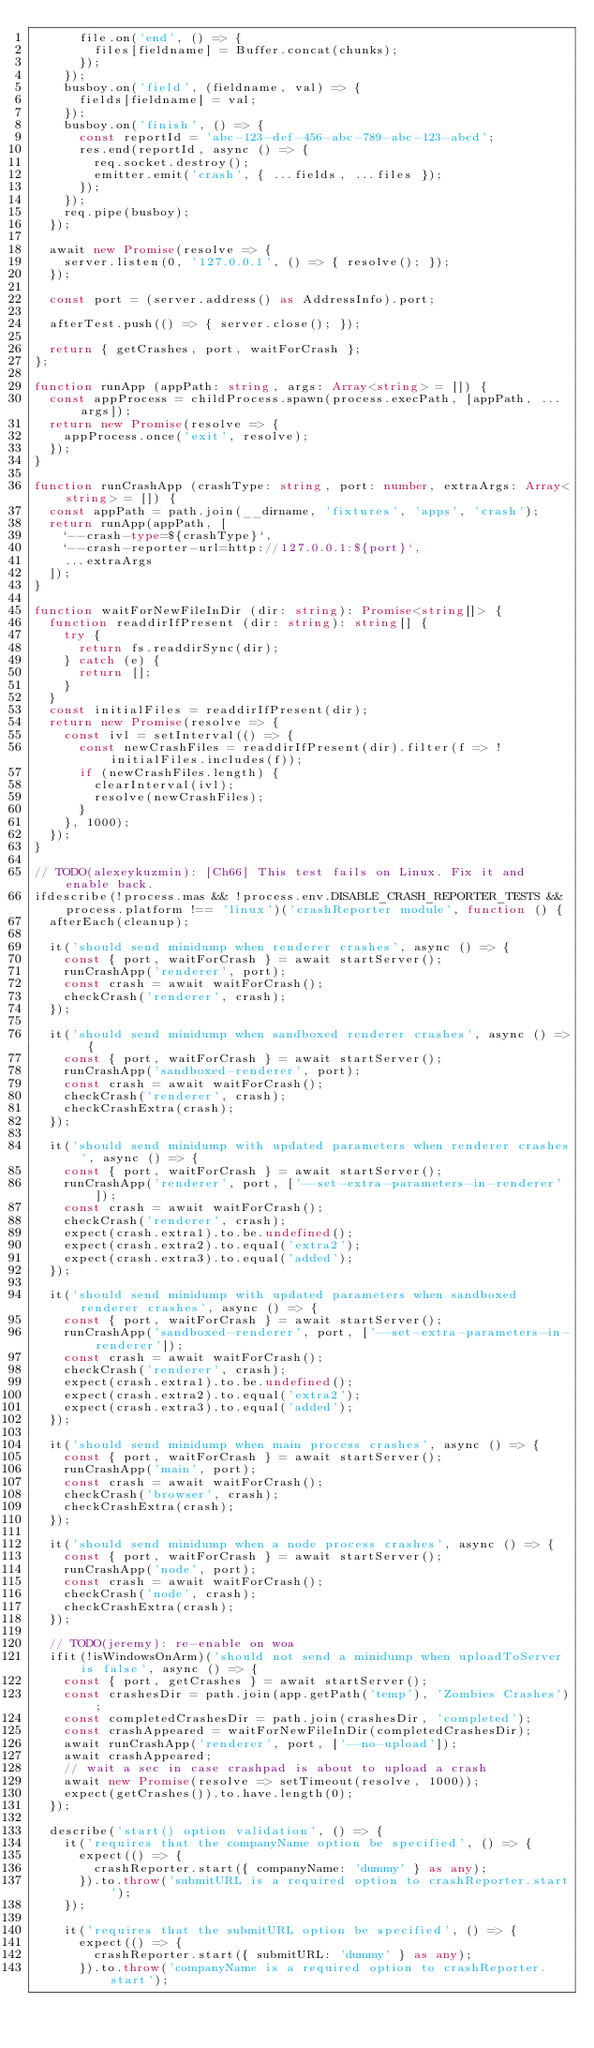Convert code to text. <code><loc_0><loc_0><loc_500><loc_500><_TypeScript_>      file.on('end', () => {
        files[fieldname] = Buffer.concat(chunks);
      });
    });
    busboy.on('field', (fieldname, val) => {
      fields[fieldname] = val;
    });
    busboy.on('finish', () => {
      const reportId = 'abc-123-def-456-abc-789-abc-123-abcd';
      res.end(reportId, async () => {
        req.socket.destroy();
        emitter.emit('crash', { ...fields, ...files });
      });
    });
    req.pipe(busboy);
  });

  await new Promise(resolve => {
    server.listen(0, '127.0.0.1', () => { resolve(); });
  });

  const port = (server.address() as AddressInfo).port;

  afterTest.push(() => { server.close(); });

  return { getCrashes, port, waitForCrash };
};

function runApp (appPath: string, args: Array<string> = []) {
  const appProcess = childProcess.spawn(process.execPath, [appPath, ...args]);
  return new Promise(resolve => {
    appProcess.once('exit', resolve);
  });
}

function runCrashApp (crashType: string, port: number, extraArgs: Array<string> = []) {
  const appPath = path.join(__dirname, 'fixtures', 'apps', 'crash');
  return runApp(appPath, [
    `--crash-type=${crashType}`,
    `--crash-reporter-url=http://127.0.0.1:${port}`,
    ...extraArgs
  ]);
}

function waitForNewFileInDir (dir: string): Promise<string[]> {
  function readdirIfPresent (dir: string): string[] {
    try {
      return fs.readdirSync(dir);
    } catch (e) {
      return [];
    }
  }
  const initialFiles = readdirIfPresent(dir);
  return new Promise(resolve => {
    const ivl = setInterval(() => {
      const newCrashFiles = readdirIfPresent(dir).filter(f => !initialFiles.includes(f));
      if (newCrashFiles.length) {
        clearInterval(ivl);
        resolve(newCrashFiles);
      }
    }, 1000);
  });
}

// TODO(alexeykuzmin): [Ch66] This test fails on Linux. Fix it and enable back.
ifdescribe(!process.mas && !process.env.DISABLE_CRASH_REPORTER_TESTS && process.platform !== 'linux')('crashReporter module', function () {
  afterEach(cleanup);

  it('should send minidump when renderer crashes', async () => {
    const { port, waitForCrash } = await startServer();
    runCrashApp('renderer', port);
    const crash = await waitForCrash();
    checkCrash('renderer', crash);
  });

  it('should send minidump when sandboxed renderer crashes', async () => {
    const { port, waitForCrash } = await startServer();
    runCrashApp('sandboxed-renderer', port);
    const crash = await waitForCrash();
    checkCrash('renderer', crash);
    checkCrashExtra(crash);
  });

  it('should send minidump with updated parameters when renderer crashes', async () => {
    const { port, waitForCrash } = await startServer();
    runCrashApp('renderer', port, ['--set-extra-parameters-in-renderer']);
    const crash = await waitForCrash();
    checkCrash('renderer', crash);
    expect(crash.extra1).to.be.undefined();
    expect(crash.extra2).to.equal('extra2');
    expect(crash.extra3).to.equal('added');
  });

  it('should send minidump with updated parameters when sandboxed renderer crashes', async () => {
    const { port, waitForCrash } = await startServer();
    runCrashApp('sandboxed-renderer', port, ['--set-extra-parameters-in-renderer']);
    const crash = await waitForCrash();
    checkCrash('renderer', crash);
    expect(crash.extra1).to.be.undefined();
    expect(crash.extra2).to.equal('extra2');
    expect(crash.extra3).to.equal('added');
  });

  it('should send minidump when main process crashes', async () => {
    const { port, waitForCrash } = await startServer();
    runCrashApp('main', port);
    const crash = await waitForCrash();
    checkCrash('browser', crash);
    checkCrashExtra(crash);
  });

  it('should send minidump when a node process crashes', async () => {
    const { port, waitForCrash } = await startServer();
    runCrashApp('node', port);
    const crash = await waitForCrash();
    checkCrash('node', crash);
    checkCrashExtra(crash);
  });

  // TODO(jeremy): re-enable on woa
  ifit(!isWindowsOnArm)('should not send a minidump when uploadToServer is false', async () => {
    const { port, getCrashes } = await startServer();
    const crashesDir = path.join(app.getPath('temp'), 'Zombies Crashes');
    const completedCrashesDir = path.join(crashesDir, 'completed');
    const crashAppeared = waitForNewFileInDir(completedCrashesDir);
    await runCrashApp('renderer', port, ['--no-upload']);
    await crashAppeared;
    // wait a sec in case crashpad is about to upload a crash
    await new Promise(resolve => setTimeout(resolve, 1000));
    expect(getCrashes()).to.have.length(0);
  });

  describe('start() option validation', () => {
    it('requires that the companyName option be specified', () => {
      expect(() => {
        crashReporter.start({ companyName: 'dummy' } as any);
      }).to.throw('submitURL is a required option to crashReporter.start');
    });

    it('requires that the submitURL option be specified', () => {
      expect(() => {
        crashReporter.start({ submitURL: 'dummy' } as any);
      }).to.throw('companyName is a required option to crashReporter.start');</code> 